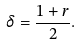<formula> <loc_0><loc_0><loc_500><loc_500>\delta = \frac { 1 + r } { 2 } .</formula> 